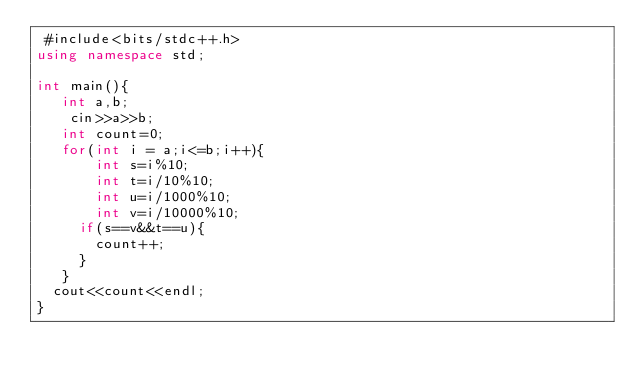<code> <loc_0><loc_0><loc_500><loc_500><_C++_> #include<bits/stdc++.h>
using namespace std;

int main(){
   int a,b;
    cin>>a>>b;
   int count=0;
   for(int i = a;i<=b;i++){
       int s=i%10;
       int t=i/10%10;
       int u=i/1000%10;
       int v=i/10000%10;
     if(s==v&&t==u){
       count++;
     }
   }
  cout<<count<<endl;
}</code> 